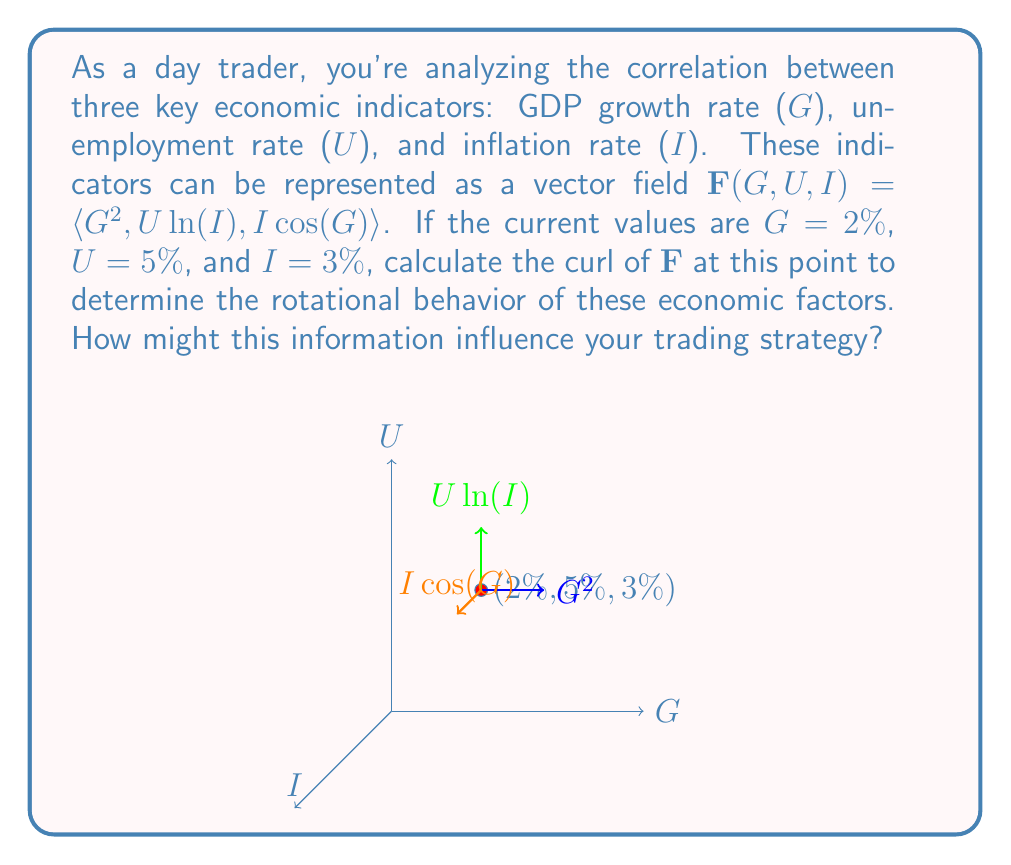Solve this math problem. Let's approach this step-by-step:

1) The curl of a vector field $\mathbf{F}(x,y,z) = \langle P,Q,R \rangle$ is given by:

   $$\text{curl }\mathbf{F} = \nabla \times \mathbf{F} = \left\langle \frac{\partial R}{\partial y} - \frac{\partial Q}{\partial z}, \frac{\partial P}{\partial z} - \frac{\partial R}{\partial x}, \frac{\partial Q}{\partial x} - \frac{\partial P}{\partial y} \right\rangle$$

2) In our case, $\mathbf{F}(G, U, I) = \langle G^2, U\ln(I), I\cos(G) \rangle$, so:
   $P = G^2$, $Q = U\ln(I)$, $R = I\cos(G)$

3) Let's calculate each partial derivative:

   $\frac{\partial R}{\partial U} = 0$
   $\frac{\partial Q}{\partial I} = \frac{U}{I}$
   $\frac{\partial P}{\partial I} = 0$
   $\frac{\partial R}{\partial G} = -I\sin(G)$
   $\frac{\partial Q}{\partial G} = 0$
   $\frac{\partial P}{\partial U} = 0$

4) Now we can compute the curl:

   $$\text{curl }\mathbf{F} = \left\langle 0 - \frac{U}{I}, 0 - (-I\sin(G)), 0 - 0 \right\rangle = \left\langle -\frac{U}{I}, I\sin(G), 0 \right\rangle$$

5) Evaluating at the given point $(G,U,I) = (2,5,3)$:

   $$\text{curl }\mathbf{F}(2,5,3) = \left\langle -\frac{5}{3}, 3\sin(2), 0 \right\rangle$$

6) This curl vector indicates the axis and magnitude of rotation of the economic factors at this point. The non-zero components suggest there's a rotational relationship between GDP growth and unemployment, and between GDP growth and inflation.

7) For a day trader, this information could be valuable. The negative x-component suggests an inverse relationship between unemployment and inflation. The positive y-component indicates a positive relationship between GDP growth and inflation. The zero z-component suggests no rotational relationship between GDP growth and unemployment at this point.

8) Trading strategy implications: You might consider positions that benefit from increasing inflation as GDP grows, or from decreasing unemployment as inflation rises. However, always consider other factors and use this as part of a broader analysis.
Answer: $\left\langle -\frac{5}{3}, 3\sin(2), 0 \right\rangle$ 